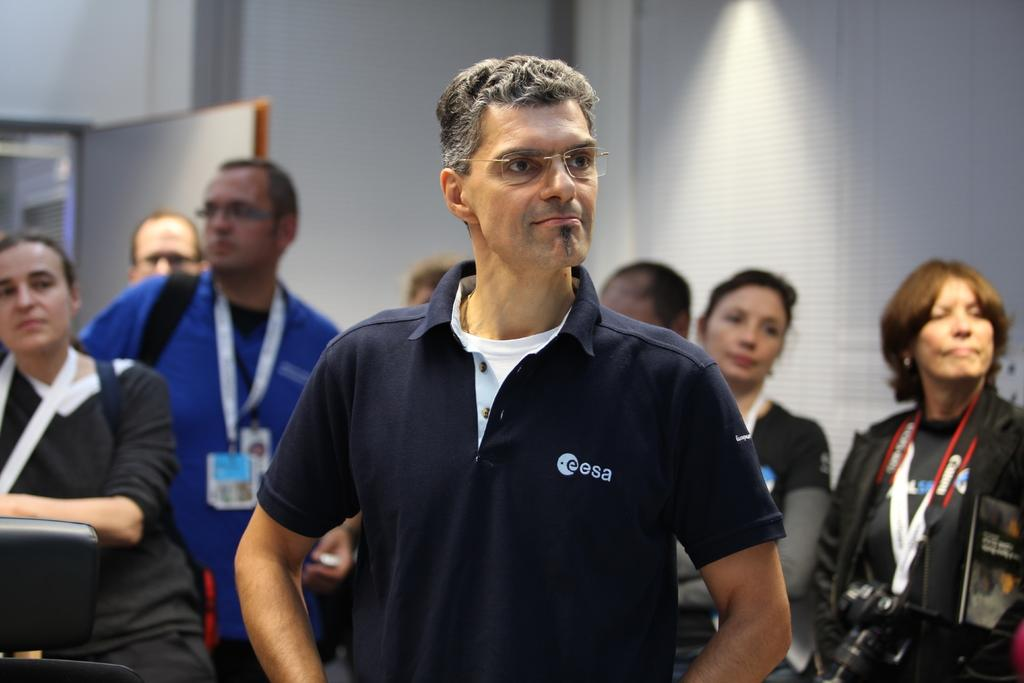What is the main subject of the image? There is a man in the image. Can you describe the man's appearance? The man is wearing spectacles and a blue t-shirt. Are there any other people in the image? Yes, there are other people in the image. What are the other people wearing? The other people are wearing ID cards. What is located on the left side of the image? There is a door on the left side of the image. Can you see any snails crawling up the hill in the image? There is no hill or snails present in the image. Is there a sink visible in the image? There is no sink present in the image. 